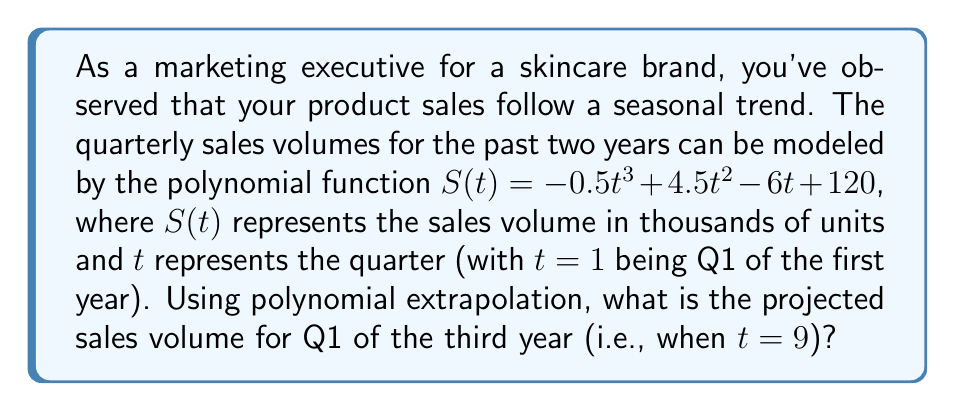Solve this math problem. To solve this problem, we need to use the given polynomial function and evaluate it for $t=9$. Let's break it down step-by-step:

1) The given polynomial function is:
   $S(t) = -0.5t^3 + 4.5t^2 - 6t + 120$

2) We need to find $S(9)$, so let's substitute $t=9$ into the function:
   $S(9) = -0.5(9^3) + 4.5(9^2) - 6(9) + 120$

3) Let's evaluate each term:
   - $-0.5(9^3) = -0.5(729) = -364.5$
   - $4.5(9^2) = 4.5(81) = 364.5$
   - $-6(9) = -54$
   - The constant term is 120

4) Now, let's sum all these terms:
   $S(9) = -364.5 + 364.5 - 54 + 120 = 66$

5) Therefore, the projected sales volume for Q1 of the third year is 66 thousand units.

This method of using a polynomial function to project future values based on past trends is known as polynomial extrapolation. It's important to note that while this method can provide useful insights, it assumes that the past trend will continue in the same pattern, which may not always be the case in real-world scenarios.
Answer: 66 thousand units 